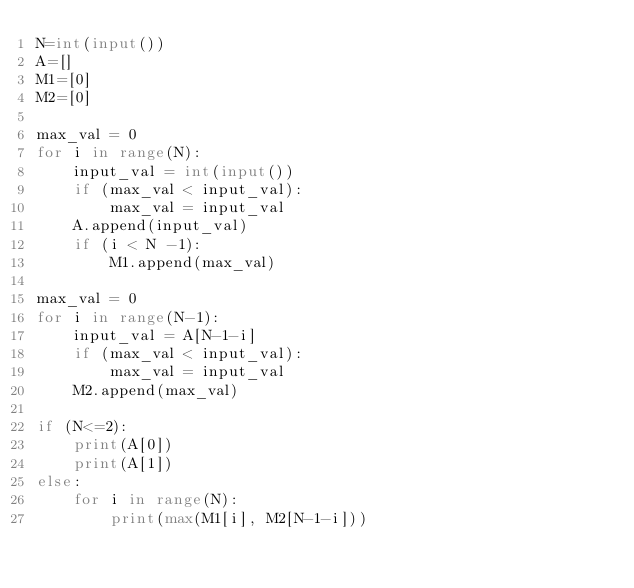<code> <loc_0><loc_0><loc_500><loc_500><_Python_>N=int(input())
A=[]
M1=[0]
M2=[0]

max_val = 0
for i in range(N):
    input_val = int(input())
    if (max_val < input_val):
        max_val = input_val
    A.append(input_val)
    if (i < N -1):
        M1.append(max_val)

max_val = 0
for i in range(N-1):
    input_val = A[N-1-i]
    if (max_val < input_val):
        max_val = input_val
    M2.append(max_val)

if (N<=2):
    print(A[0])
    print(A[1])
else:
    for i in range(N):
        print(max(M1[i], M2[N-1-i]))
</code> 